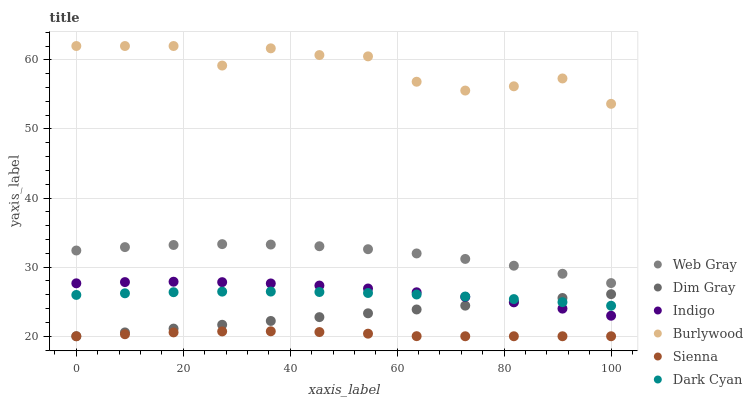Does Sienna have the minimum area under the curve?
Answer yes or no. Yes. Does Burlywood have the maximum area under the curve?
Answer yes or no. Yes. Does Indigo have the minimum area under the curve?
Answer yes or no. No. Does Indigo have the maximum area under the curve?
Answer yes or no. No. Is Dim Gray the smoothest?
Answer yes or no. Yes. Is Burlywood the roughest?
Answer yes or no. Yes. Is Indigo the smoothest?
Answer yes or no. No. Is Indigo the roughest?
Answer yes or no. No. Does Dim Gray have the lowest value?
Answer yes or no. Yes. Does Indigo have the lowest value?
Answer yes or no. No. Does Burlywood have the highest value?
Answer yes or no. Yes. Does Indigo have the highest value?
Answer yes or no. No. Is Sienna less than Indigo?
Answer yes or no. Yes. Is Web Gray greater than Sienna?
Answer yes or no. Yes. Does Dark Cyan intersect Indigo?
Answer yes or no. Yes. Is Dark Cyan less than Indigo?
Answer yes or no. No. Is Dark Cyan greater than Indigo?
Answer yes or no. No. Does Sienna intersect Indigo?
Answer yes or no. No. 